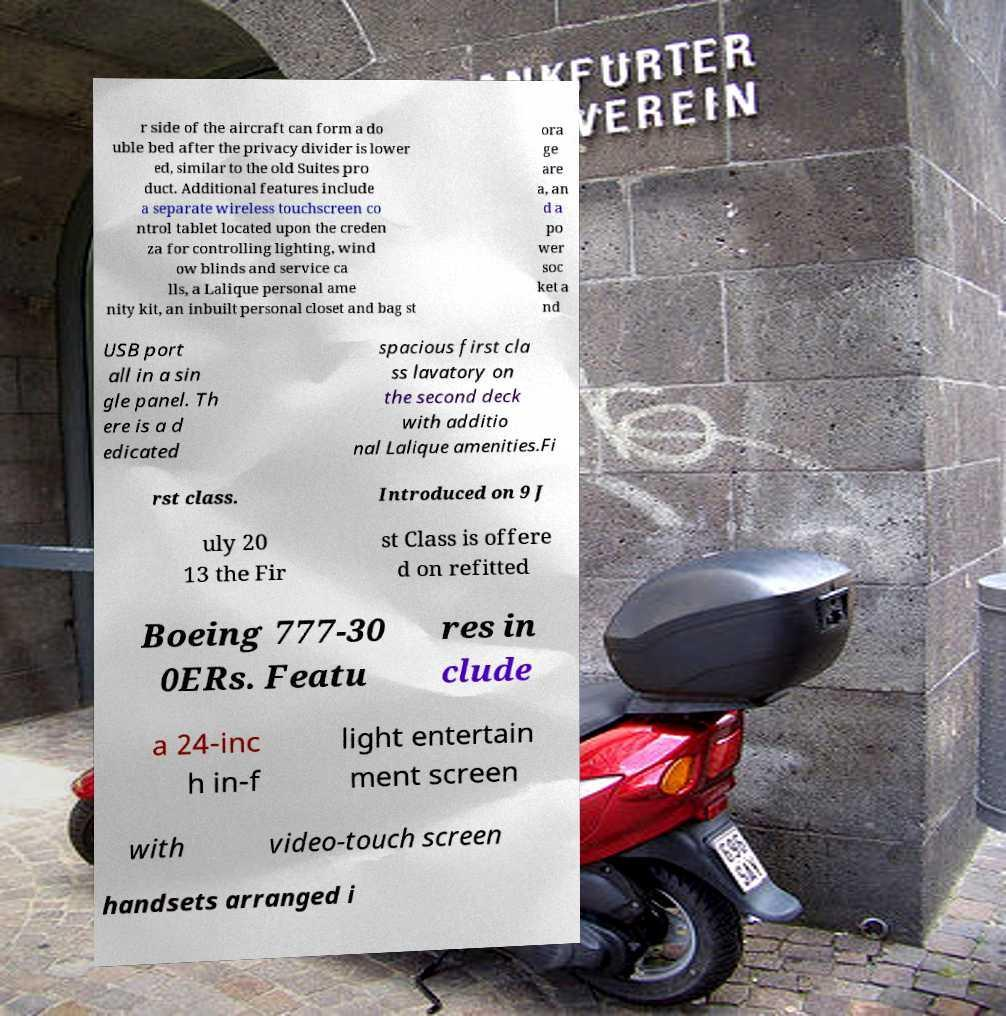Please identify and transcribe the text found in this image. r side of the aircraft can form a do uble bed after the privacy divider is lower ed, similar to the old Suites pro duct. Additional features include a separate wireless touchscreen co ntrol tablet located upon the creden za for controlling lighting, wind ow blinds and service ca lls, a Lalique personal ame nity kit, an inbuilt personal closet and bag st ora ge are a, an d a po wer soc ket a nd USB port all in a sin gle panel. Th ere is a d edicated spacious first cla ss lavatory on the second deck with additio nal Lalique amenities.Fi rst class. Introduced on 9 J uly 20 13 the Fir st Class is offere d on refitted Boeing 777-30 0ERs. Featu res in clude a 24-inc h in-f light entertain ment screen with video-touch screen handsets arranged i 